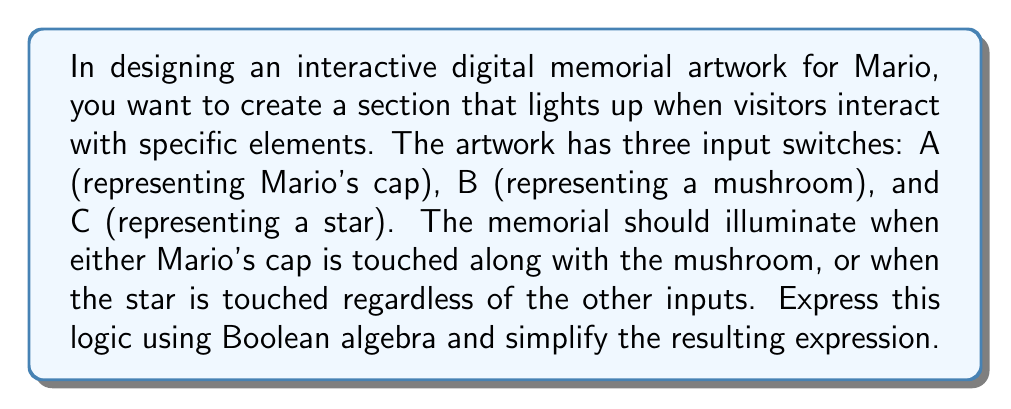Provide a solution to this math problem. Let's approach this step-by-step:

1) First, let's translate the given conditions into Boolean expressions:
   - Mario's cap (A) AND mushroom (B): $A \cdot B$
   - Star (C) regardless of other inputs: $C$

2) We want either of these conditions to be true, so we use the OR operation:
   $$(A \cdot B) + C$$

3) This expression is already in its simplest form. We can verify this using the laws of Boolean algebra:

   a) We can't apply the distributive law because C is not common to both terms.
   b) We can't apply absorption law because neither A nor B appears alone.
   c) We can't apply complementation because we don't have any negated variables.

4) Therefore, the final simplified Boolean expression is:
   $$(A \cdot B) + C$$

This expression accurately represents the logic for the interactive elements in the digital memorial artwork for Mario.
Answer: $(A \cdot B) + C$ 